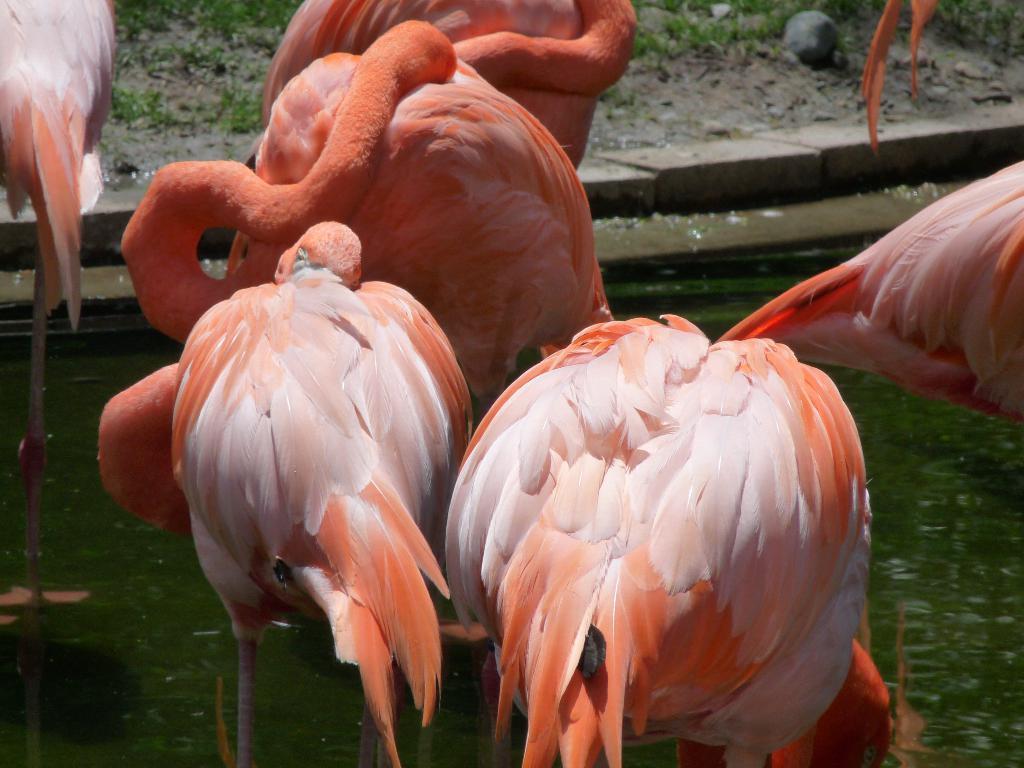In one or two sentences, can you explain what this image depicts? In this image we can see a group of flamingo birds, here is the water, here is the grass. 